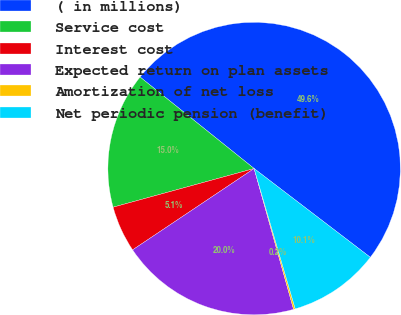Convert chart. <chart><loc_0><loc_0><loc_500><loc_500><pie_chart><fcel>( in millions)<fcel>Service cost<fcel>Interest cost<fcel>Expected return on plan assets<fcel>Amortization of net loss<fcel>Net periodic pension (benefit)<nl><fcel>49.62%<fcel>15.02%<fcel>5.13%<fcel>19.96%<fcel>0.19%<fcel>10.08%<nl></chart> 